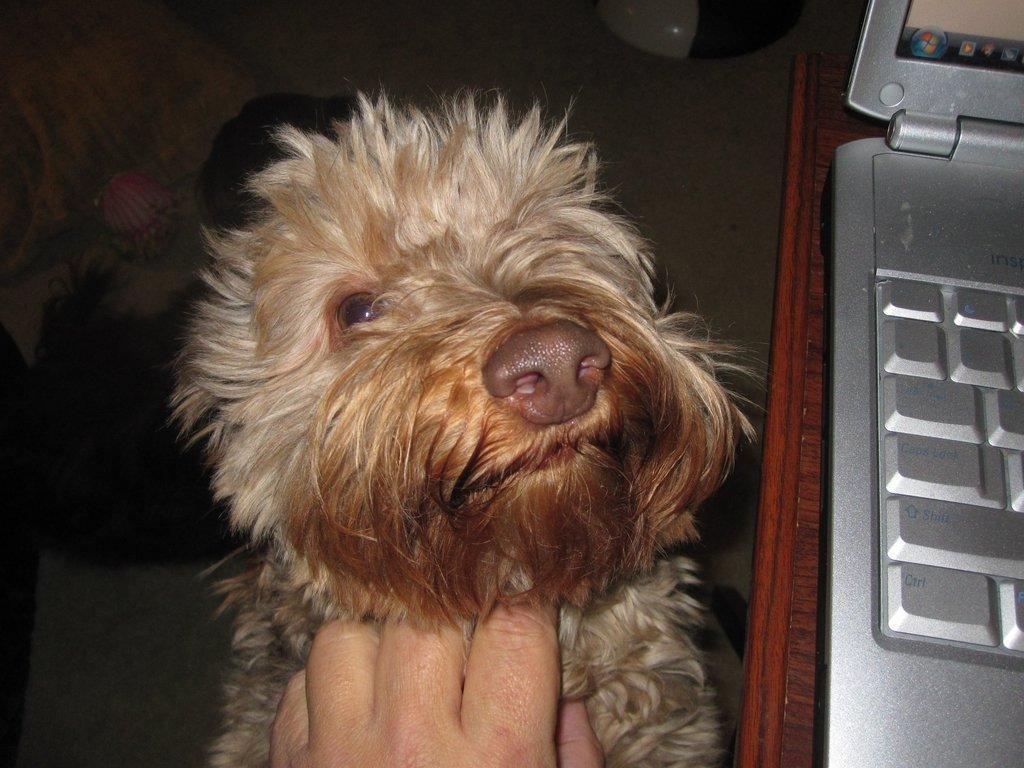Describe this image in one or two sentences. In the center of the image we can see a dog and there is also some person's hand on the dog. On the right there is a laptop placed on the wooden surface. 